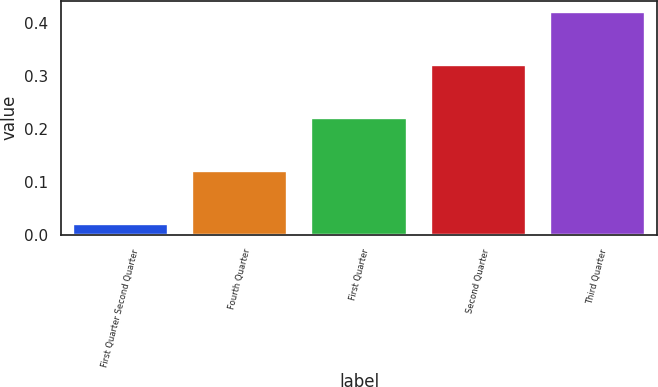Convert chart. <chart><loc_0><loc_0><loc_500><loc_500><bar_chart><fcel>First Quarter Second Quarter<fcel>Fourth Quarter<fcel>First Quarter<fcel>Second Quarter<fcel>Third Quarter<nl><fcel>0.02<fcel>0.12<fcel>0.22<fcel>0.32<fcel>0.42<nl></chart> 